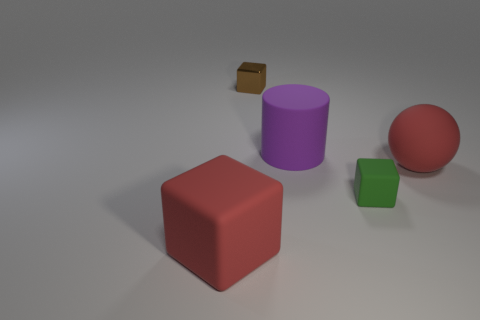Add 4 cyan matte cubes. How many objects exist? 9 Subtract all blocks. How many objects are left? 2 Subtract 0 brown spheres. How many objects are left? 5 Subtract all large green blocks. Subtract all big red rubber balls. How many objects are left? 4 Add 3 rubber spheres. How many rubber spheres are left? 4 Add 5 purple cylinders. How many purple cylinders exist? 6 